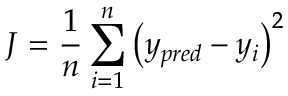<formula> <loc_0><loc_0><loc_500><loc_500>J = \frac { 1 } { n } \sum _ { i = 1 } ^ { n } \left ( y _ { p r e d } - y _ { i } \right ) ^ { 2 }</formula> 